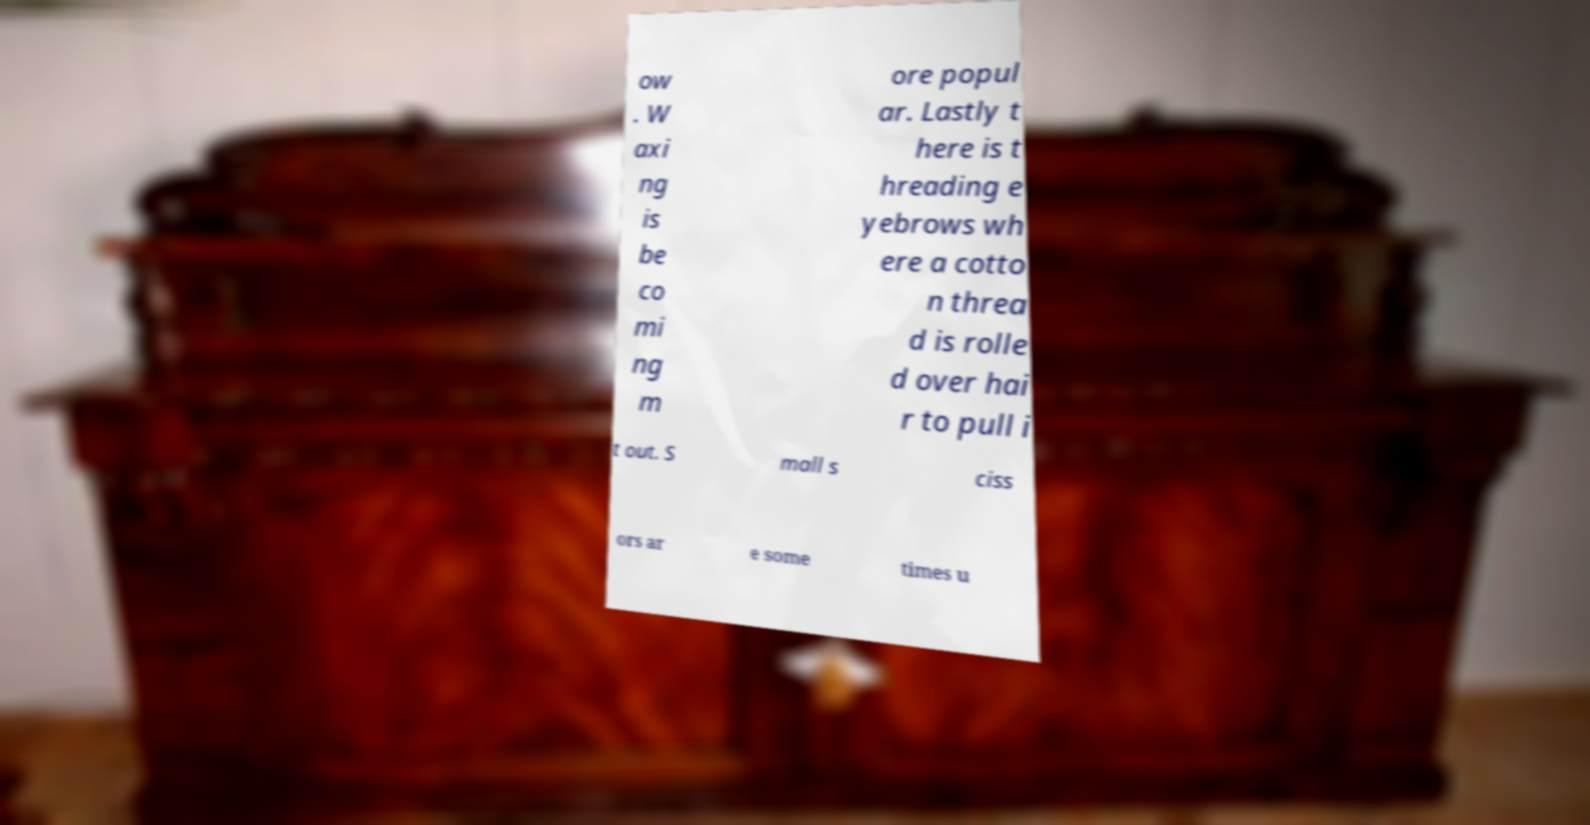For documentation purposes, I need the text within this image transcribed. Could you provide that? ow . W axi ng is be co mi ng m ore popul ar. Lastly t here is t hreading e yebrows wh ere a cotto n threa d is rolle d over hai r to pull i t out. S mall s ciss ors ar e some times u 